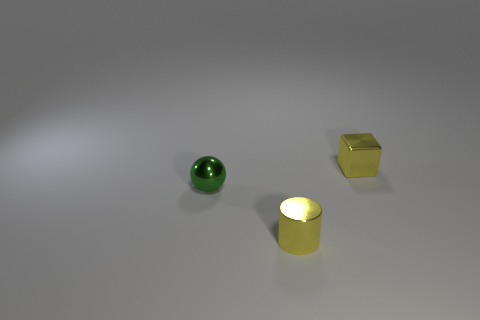Are there more small yellow shiny things than large brown matte blocks?
Give a very brief answer. Yes. What size is the metallic thing that is on the right side of the tiny sphere and in front of the small yellow block?
Offer a very short reply. Small. What is the shape of the green thing?
Ensure brevity in your answer.  Sphere. Is there anything else that has the same size as the metal cube?
Provide a succinct answer. Yes. Are there more small things that are in front of the green object than green rubber cubes?
Provide a short and direct response. Yes. What shape is the tiny yellow metallic object that is behind the small green thing that is in front of the metallic thing that is behind the green shiny sphere?
Offer a very short reply. Cube. There is a thing behind the sphere; is its size the same as the small yellow metal cylinder?
Keep it short and to the point. Yes. What shape is the metallic object that is both in front of the yellow metallic cube and behind the small yellow metallic cylinder?
Make the answer very short. Sphere. Do the metallic cylinder and the metallic thing that is behind the small green object have the same color?
Offer a terse response. Yes. What is the color of the tiny object that is in front of the tiny object left of the yellow metal thing that is in front of the small green sphere?
Offer a very short reply. Yellow. 